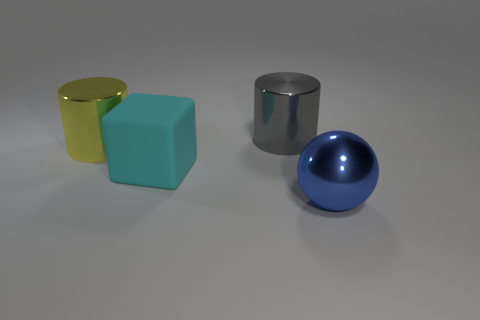Are there any large gray cylinders on the left side of the yellow cylinder?
Provide a succinct answer. No. What size is the metal object that is behind the cube and to the right of the big cyan matte cube?
Give a very brief answer. Large. What number of things are big gray objects or matte cubes?
Give a very brief answer. 2. There is a ball; is its size the same as the metallic cylinder left of the large cyan thing?
Provide a succinct answer. Yes. There is a metallic cylinder that is on the right side of the metallic cylinder to the left of the metal cylinder that is behind the large yellow shiny object; what is its size?
Offer a terse response. Large. Are there any blue metallic spheres?
Give a very brief answer. Yes. How many other objects are the same color as the matte thing?
Give a very brief answer. 0. How many objects are things on the right side of the yellow thing or big metal objects right of the cyan block?
Your answer should be very brief. 3. There is a shiny object left of the large gray thing; how many big metallic objects are behind it?
Make the answer very short. 1. There is a ball that is the same material as the large yellow thing; what is its color?
Offer a terse response. Blue. 